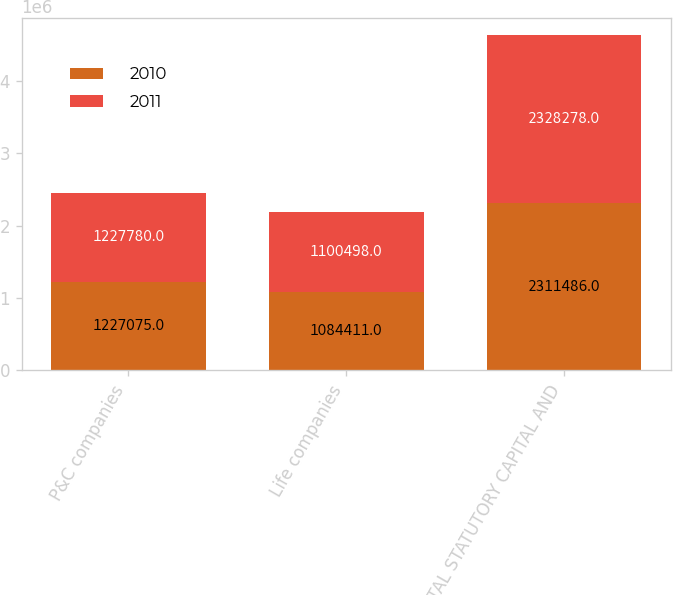Convert chart. <chart><loc_0><loc_0><loc_500><loc_500><stacked_bar_chart><ecel><fcel>P&C companies<fcel>Life companies<fcel>TOTAL STATUTORY CAPITAL AND<nl><fcel>2010<fcel>1.22708e+06<fcel>1.08441e+06<fcel>2.31149e+06<nl><fcel>2011<fcel>1.22778e+06<fcel>1.1005e+06<fcel>2.32828e+06<nl></chart> 